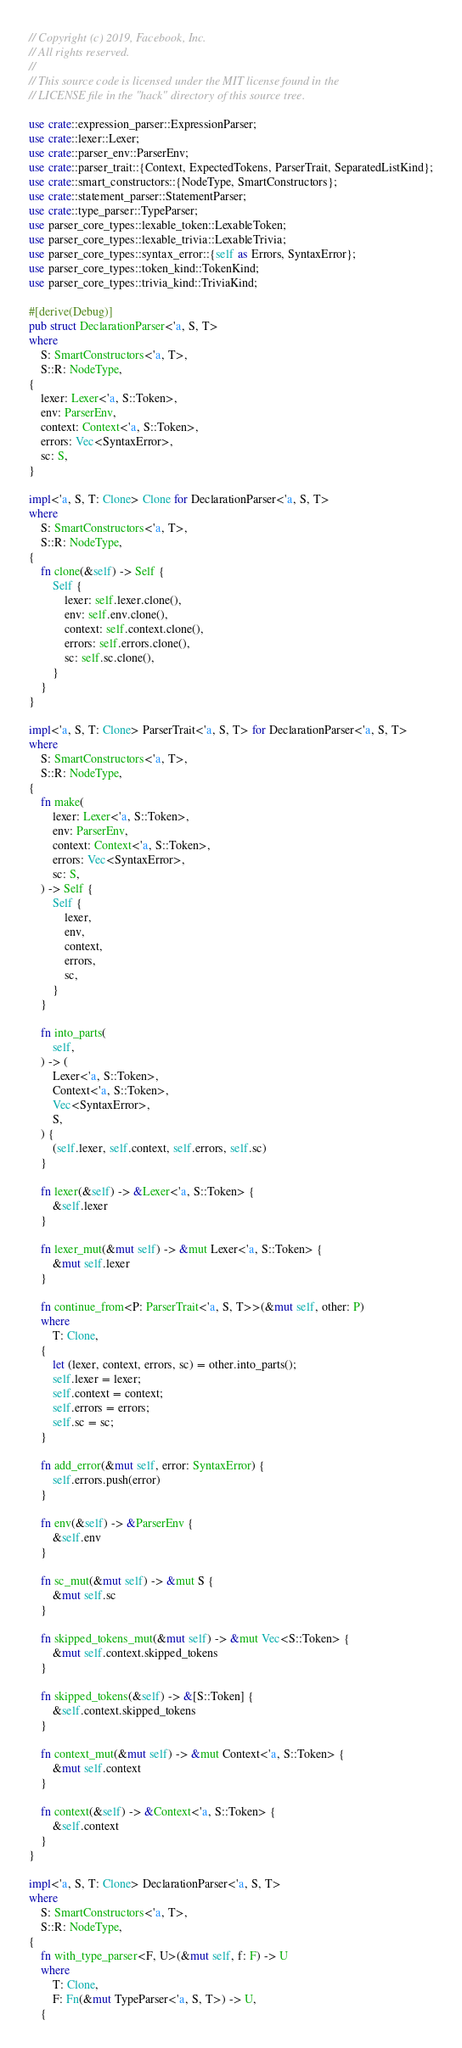<code> <loc_0><loc_0><loc_500><loc_500><_Rust_>// Copyright (c) 2019, Facebook, Inc.
// All rights reserved.
//
// This source code is licensed under the MIT license found in the
// LICENSE file in the "hack" directory of this source tree.

use crate::expression_parser::ExpressionParser;
use crate::lexer::Lexer;
use crate::parser_env::ParserEnv;
use crate::parser_trait::{Context, ExpectedTokens, ParserTrait, SeparatedListKind};
use crate::smart_constructors::{NodeType, SmartConstructors};
use crate::statement_parser::StatementParser;
use crate::type_parser::TypeParser;
use parser_core_types::lexable_token::LexableToken;
use parser_core_types::lexable_trivia::LexableTrivia;
use parser_core_types::syntax_error::{self as Errors, SyntaxError};
use parser_core_types::token_kind::TokenKind;
use parser_core_types::trivia_kind::TriviaKind;

#[derive(Debug)]
pub struct DeclarationParser<'a, S, T>
where
    S: SmartConstructors<'a, T>,
    S::R: NodeType,
{
    lexer: Lexer<'a, S::Token>,
    env: ParserEnv,
    context: Context<'a, S::Token>,
    errors: Vec<SyntaxError>,
    sc: S,
}

impl<'a, S, T: Clone> Clone for DeclarationParser<'a, S, T>
where
    S: SmartConstructors<'a, T>,
    S::R: NodeType,
{
    fn clone(&self) -> Self {
        Self {
            lexer: self.lexer.clone(),
            env: self.env.clone(),
            context: self.context.clone(),
            errors: self.errors.clone(),
            sc: self.sc.clone(),
        }
    }
}

impl<'a, S, T: Clone> ParserTrait<'a, S, T> for DeclarationParser<'a, S, T>
where
    S: SmartConstructors<'a, T>,
    S::R: NodeType,
{
    fn make(
        lexer: Lexer<'a, S::Token>,
        env: ParserEnv,
        context: Context<'a, S::Token>,
        errors: Vec<SyntaxError>,
        sc: S,
    ) -> Self {
        Self {
            lexer,
            env,
            context,
            errors,
            sc,
        }
    }

    fn into_parts(
        self,
    ) -> (
        Lexer<'a, S::Token>,
        Context<'a, S::Token>,
        Vec<SyntaxError>,
        S,
    ) {
        (self.lexer, self.context, self.errors, self.sc)
    }

    fn lexer(&self) -> &Lexer<'a, S::Token> {
        &self.lexer
    }

    fn lexer_mut(&mut self) -> &mut Lexer<'a, S::Token> {
        &mut self.lexer
    }

    fn continue_from<P: ParserTrait<'a, S, T>>(&mut self, other: P)
    where
        T: Clone,
    {
        let (lexer, context, errors, sc) = other.into_parts();
        self.lexer = lexer;
        self.context = context;
        self.errors = errors;
        self.sc = sc;
    }

    fn add_error(&mut self, error: SyntaxError) {
        self.errors.push(error)
    }

    fn env(&self) -> &ParserEnv {
        &self.env
    }

    fn sc_mut(&mut self) -> &mut S {
        &mut self.sc
    }

    fn skipped_tokens_mut(&mut self) -> &mut Vec<S::Token> {
        &mut self.context.skipped_tokens
    }

    fn skipped_tokens(&self) -> &[S::Token] {
        &self.context.skipped_tokens
    }

    fn context_mut(&mut self) -> &mut Context<'a, S::Token> {
        &mut self.context
    }

    fn context(&self) -> &Context<'a, S::Token> {
        &self.context
    }
}

impl<'a, S, T: Clone> DeclarationParser<'a, S, T>
where
    S: SmartConstructors<'a, T>,
    S::R: NodeType,
{
    fn with_type_parser<F, U>(&mut self, f: F) -> U
    where
        T: Clone,
        F: Fn(&mut TypeParser<'a, S, T>) -> U,
    {</code> 